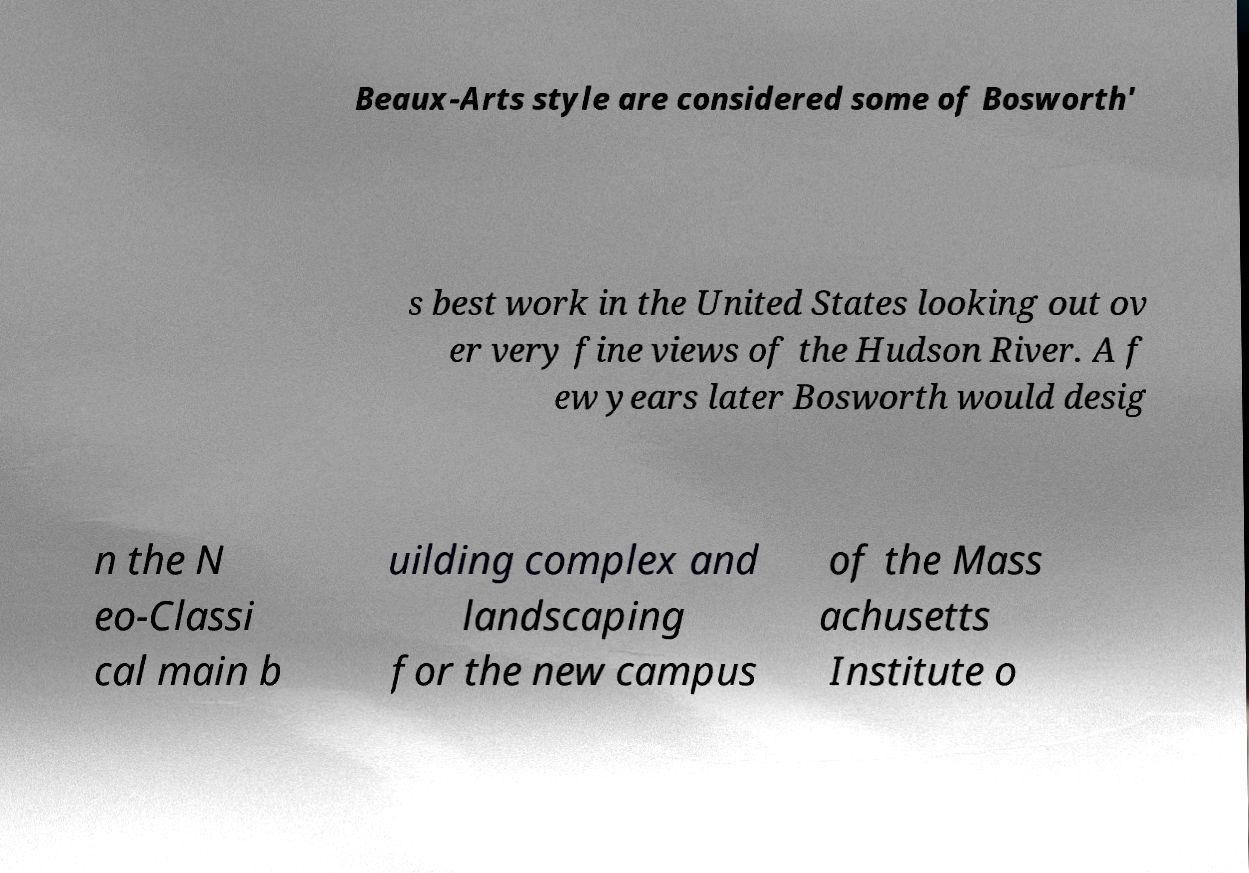For documentation purposes, I need the text within this image transcribed. Could you provide that? Beaux-Arts style are considered some of Bosworth' s best work in the United States looking out ov er very fine views of the Hudson River. A f ew years later Bosworth would desig n the N eo-Classi cal main b uilding complex and landscaping for the new campus of the Mass achusetts Institute o 